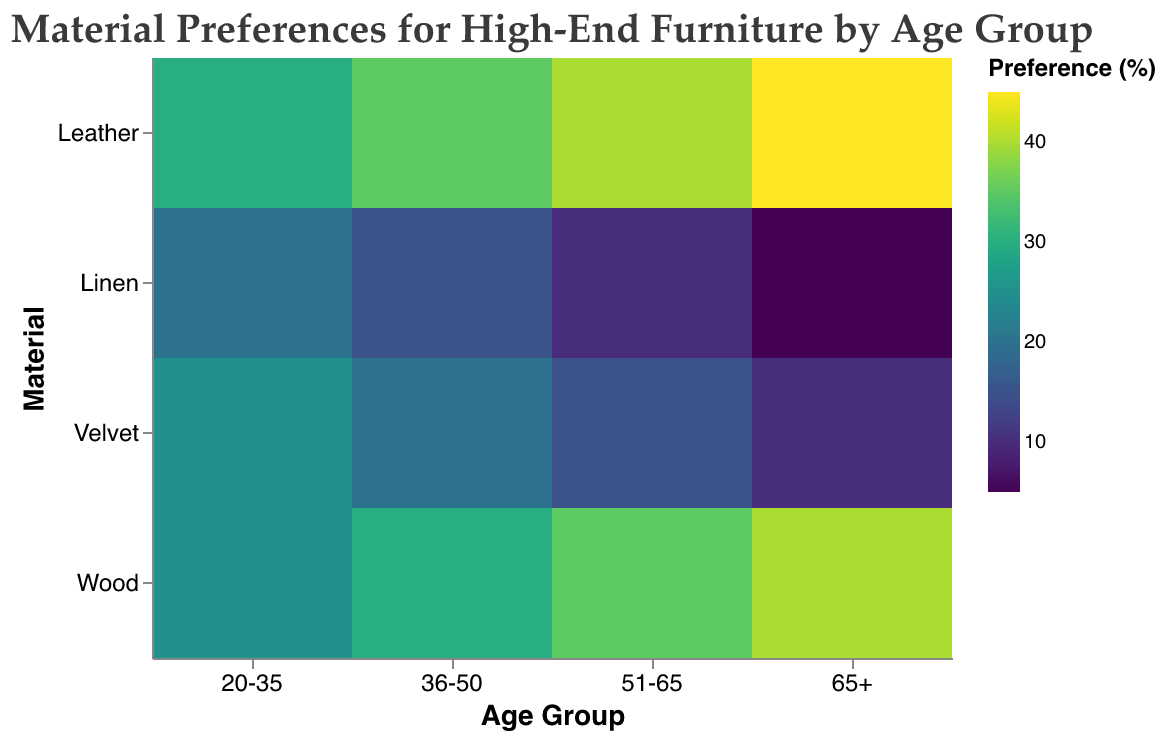What is the most preferred material for the age group 65+? Refer to the color intensity and size of the blocks within the 65+ age group; the most preference is shown for the material with the largest block and darkest color.
Answer: Leather What material has the least preference among the 20-35 age group? Look for the smallest and lightest-colored block in the 20-35 age group column.
Answer: Linen Which age group has the highest preference for wood materials? Compare the sizes and colors of the Wood blocks across all age groups.
Answer: 65+ What is the combined preference percentage for Velvet and Linen in the 36-50 age group? Sum the values of the Velvet and Linen blocks for the 36-50 age group. Velvet is 20%, and Linen is 15%, so the total is 20% + 15% = 35%.
Answer: 35% Compare the preference for Leather in the 51-65 age group to the preference for Wood in the same age group. Which one is higher? Contrast the size and color intensity of the Leather and Wood blocks within the 51-65 age group. Leather has a 40% preference, while Wood has a 35% preference.
Answer: Leather Which material does the age group 36-50 have the highest preference for? Check the 36-50 age group column to find the largest and darkest-colored block.
Answer: Leather How does the preference for Velvet in the 65+ age group compare to Velvet in the 20-35 age group? Compare the sizes and intensities of the Velvet blocks in the columns for 65+ and 20-35 age groups.
Answer: Less in 65+ What is the total preference percentage for Leather across all age groups? Add the preference percentages for Leather in all age groups: 30% + 35% + 40% + 45% = 150%.
Answer: 150% Which age group shows the least variation in material preferences? Identify the age group with the smallest range between the highest and lowest preference percentages across materials. The 36-50 group ranges between 15% and 35%.
Answer: 36-50 Is Velvet generally more preferred by younger or older age groups? Observe the colors and sizes of the Velvet blocks across age groups. Velvet has higher preferences in younger age groups and lower in older age groups.
Answer: Younger 